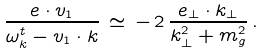<formula> <loc_0><loc_0><loc_500><loc_500>\frac { { e } \cdot { v } _ { 1 } } { \omega _ { k } ^ { t } - { v } _ { 1 } \cdot { k } } \, \simeq \, - \, 2 \, \frac { { e } _ { \perp } \cdot { k } _ { \perp } } { { k } _ { \perp } ^ { 2 } + m _ { g } ^ { 2 } } \, .</formula> 